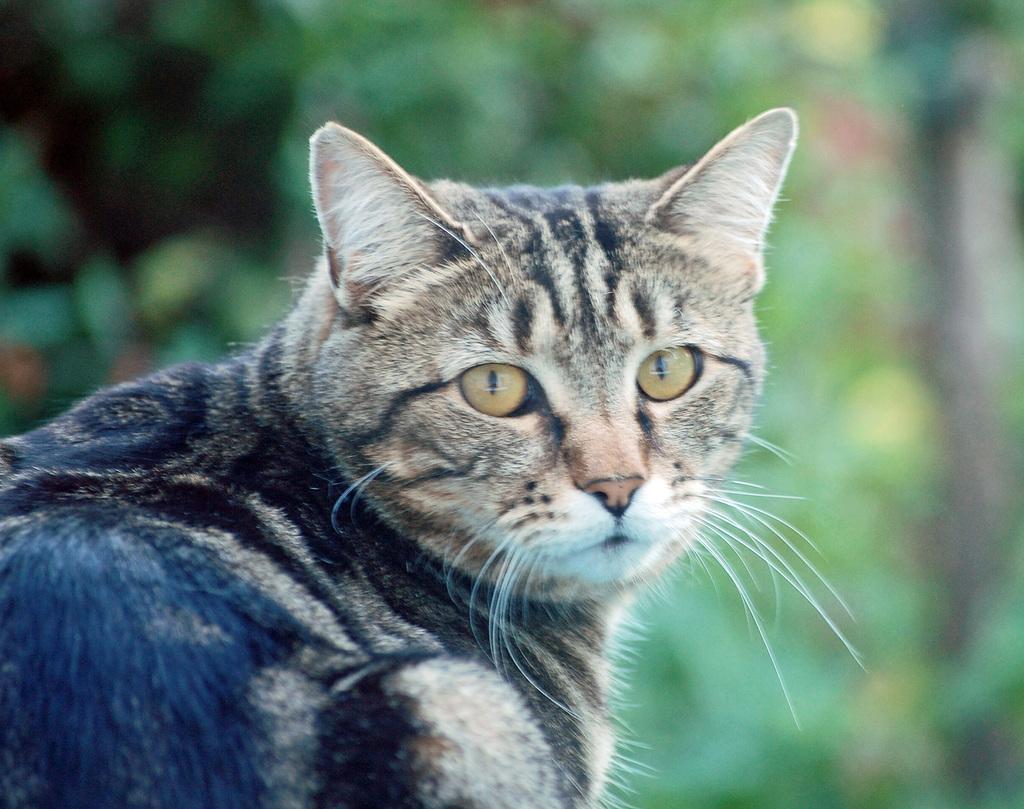Please provide a concise description of this image. In the image in the center,we can see one cat,which is in black and brown color. In the background we can see trees. 